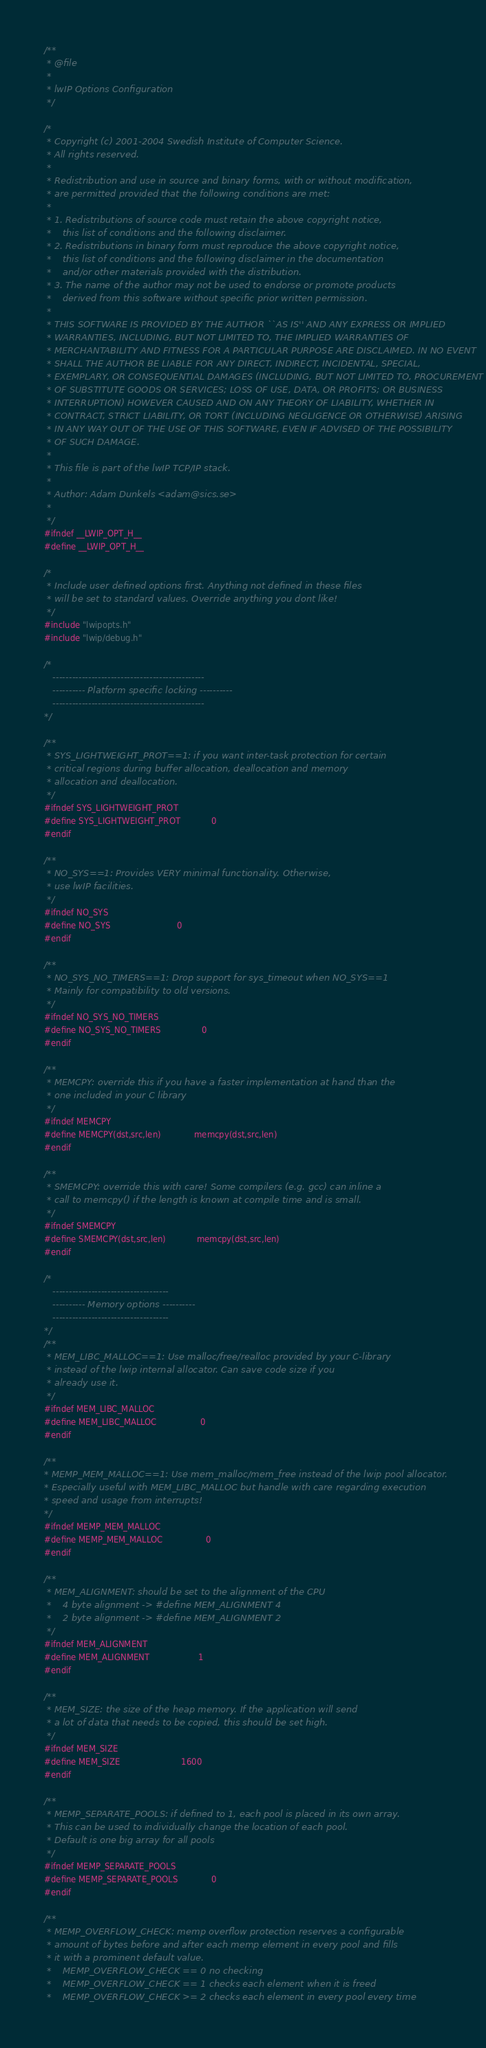<code> <loc_0><loc_0><loc_500><loc_500><_C_>/**
 * @file
 *
 * lwIP Options Configuration
 */

/*
 * Copyright (c) 2001-2004 Swedish Institute of Computer Science.
 * All rights reserved. 
 * 
 * Redistribution and use in source and binary forms, with or without modification, 
 * are permitted provided that the following conditions are met:
 *
 * 1. Redistributions of source code must retain the above copyright notice,
 *    this list of conditions and the following disclaimer.
 * 2. Redistributions in binary form must reproduce the above copyright notice,
 *    this list of conditions and the following disclaimer in the documentation
 *    and/or other materials provided with the distribution.
 * 3. The name of the author may not be used to endorse or promote products
 *    derived from this software without specific prior written permission. 
 *
 * THIS SOFTWARE IS PROVIDED BY THE AUTHOR ``AS IS'' AND ANY EXPRESS OR IMPLIED 
 * WARRANTIES, INCLUDING, BUT NOT LIMITED TO, THE IMPLIED WARRANTIES OF 
 * MERCHANTABILITY AND FITNESS FOR A PARTICULAR PURPOSE ARE DISCLAIMED. IN NO EVENT 
 * SHALL THE AUTHOR BE LIABLE FOR ANY DIRECT, INDIRECT, INCIDENTAL, SPECIAL, 
 * EXEMPLARY, OR CONSEQUENTIAL DAMAGES (INCLUDING, BUT NOT LIMITED TO, PROCUREMENT 
 * OF SUBSTITUTE GOODS OR SERVICES; LOSS OF USE, DATA, OR PROFITS; OR BUSINESS 
 * INTERRUPTION) HOWEVER CAUSED AND ON ANY THEORY OF LIABILITY, WHETHER IN 
 * CONTRACT, STRICT LIABILITY, OR TORT (INCLUDING NEGLIGENCE OR OTHERWISE) ARISING 
 * IN ANY WAY OUT OF THE USE OF THIS SOFTWARE, EVEN IF ADVISED OF THE POSSIBILITY 
 * OF SUCH DAMAGE.
 *
 * This file is part of the lwIP TCP/IP stack.
 * 
 * Author: Adam Dunkels <adam@sics.se>
 *
 */
#ifndef __LWIP_OPT_H__
#define __LWIP_OPT_H__

/*
 * Include user defined options first. Anything not defined in these files
 * will be set to standard values. Override anything you dont like!
 */
#include "lwipopts.h"
#include "lwip/debug.h"

/*
   -----------------------------------------------
   ---------- Platform specific locking ----------
   -----------------------------------------------
*/

/**
 * SYS_LIGHTWEIGHT_PROT==1: if you want inter-task protection for certain
 * critical regions during buffer allocation, deallocation and memory
 * allocation and deallocation.
 */
#ifndef SYS_LIGHTWEIGHT_PROT
#define SYS_LIGHTWEIGHT_PROT            0
#endif

/** 
 * NO_SYS==1: Provides VERY minimal functionality. Otherwise,
 * use lwIP facilities.
 */
#ifndef NO_SYS
#define NO_SYS                          0
#endif

/**
 * NO_SYS_NO_TIMERS==1: Drop support for sys_timeout when NO_SYS==1
 * Mainly for compatibility to old versions.
 */
#ifndef NO_SYS_NO_TIMERS
#define NO_SYS_NO_TIMERS                0
#endif

/**
 * MEMCPY: override this if you have a faster implementation at hand than the
 * one included in your C library
 */
#ifndef MEMCPY
#define MEMCPY(dst,src,len)             memcpy(dst,src,len)
#endif

/**
 * SMEMCPY: override this with care! Some compilers (e.g. gcc) can inline a
 * call to memcpy() if the length is known at compile time and is small.
 */
#ifndef SMEMCPY
#define SMEMCPY(dst,src,len)            memcpy(dst,src,len)
#endif

/*
   ------------------------------------
   ---------- Memory options ----------
   ------------------------------------
*/
/**
 * MEM_LIBC_MALLOC==1: Use malloc/free/realloc provided by your C-library
 * instead of the lwip internal allocator. Can save code size if you
 * already use it.
 */
#ifndef MEM_LIBC_MALLOC
#define MEM_LIBC_MALLOC                 0
#endif

/**
* MEMP_MEM_MALLOC==1: Use mem_malloc/mem_free instead of the lwip pool allocator.
* Especially useful with MEM_LIBC_MALLOC but handle with care regarding execution
* speed and usage from interrupts!
*/
#ifndef MEMP_MEM_MALLOC
#define MEMP_MEM_MALLOC                 0
#endif

/**
 * MEM_ALIGNMENT: should be set to the alignment of the CPU
 *    4 byte alignment -> #define MEM_ALIGNMENT 4
 *    2 byte alignment -> #define MEM_ALIGNMENT 2
 */
#ifndef MEM_ALIGNMENT
#define MEM_ALIGNMENT                   1
#endif

/**
 * MEM_SIZE: the size of the heap memory. If the application will send
 * a lot of data that needs to be copied, this should be set high.
 */
#ifndef MEM_SIZE
#define MEM_SIZE                        1600
#endif

/**
 * MEMP_SEPARATE_POOLS: if defined to 1, each pool is placed in its own array.
 * This can be used to individually change the location of each pool.
 * Default is one big array for all pools
 */
#ifndef MEMP_SEPARATE_POOLS
#define MEMP_SEPARATE_POOLS             0
#endif

/**
 * MEMP_OVERFLOW_CHECK: memp overflow protection reserves a configurable
 * amount of bytes before and after each memp element in every pool and fills
 * it with a prominent default value.
 *    MEMP_OVERFLOW_CHECK == 0 no checking
 *    MEMP_OVERFLOW_CHECK == 1 checks each element when it is freed
 *    MEMP_OVERFLOW_CHECK >= 2 checks each element in every pool every time</code> 